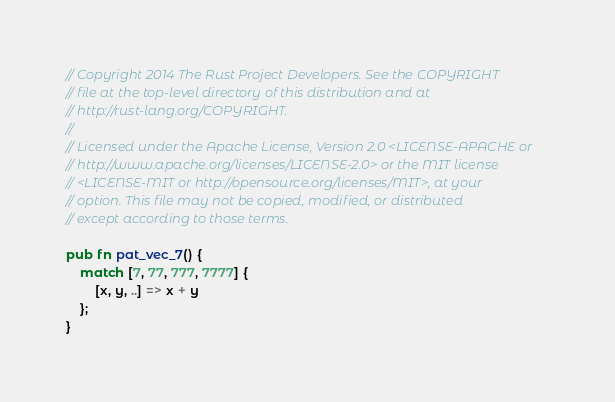Convert code to text. <code><loc_0><loc_0><loc_500><loc_500><_Rust_>// Copyright 2014 The Rust Project Developers. See the COPYRIGHT
// file at the top-level directory of this distribution and at
// http://rust-lang.org/COPYRIGHT.
//
// Licensed under the Apache License, Version 2.0 <LICENSE-APACHE or
// http://www.apache.org/licenses/LICENSE-2.0> or the MIT license
// <LICENSE-MIT or http://opensource.org/licenses/MIT>, at your
// option. This file may not be copied, modified, or distributed
// except according to those terms.

pub fn pat_vec_7() {
    match [7, 77, 777, 7777] {
        [x, y, ..] => x + y
    };
}
</code> 